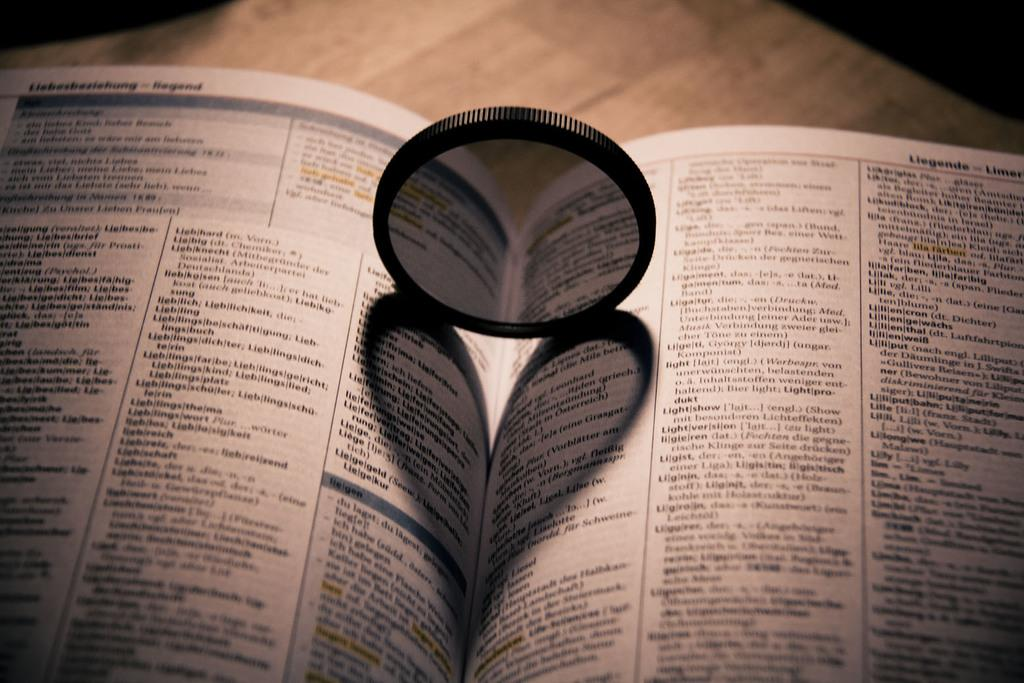<image>
Present a compact description of the photo's key features. A book is open to a page labeled Liegende on the right. 